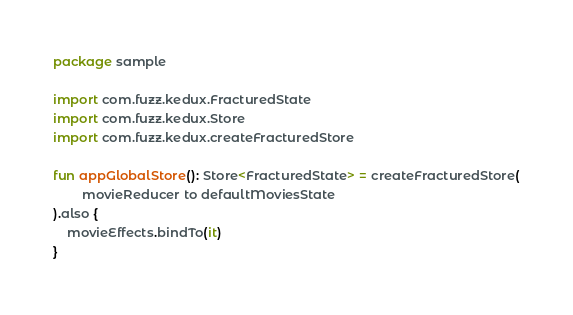Convert code to text. <code><loc_0><loc_0><loc_500><loc_500><_Kotlin_>package sample

import com.fuzz.kedux.FracturedState
import com.fuzz.kedux.Store
import com.fuzz.kedux.createFracturedStore

fun appGlobalStore(): Store<FracturedState> = createFracturedStore(
        movieReducer to defaultMoviesState
).also {
    movieEffects.bindTo(it)
}
</code> 